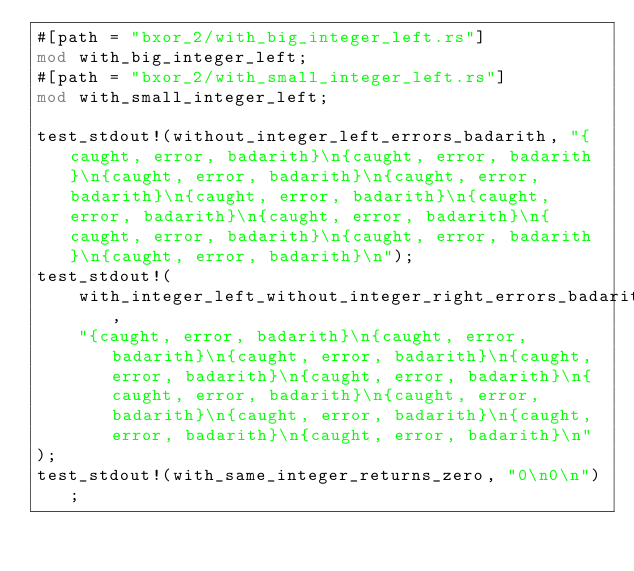Convert code to text. <code><loc_0><loc_0><loc_500><loc_500><_Rust_>#[path = "bxor_2/with_big_integer_left.rs"]
mod with_big_integer_left;
#[path = "bxor_2/with_small_integer_left.rs"]
mod with_small_integer_left;

test_stdout!(without_integer_left_errors_badarith, "{caught, error, badarith}\n{caught, error, badarith}\n{caught, error, badarith}\n{caught, error, badarith}\n{caught, error, badarith}\n{caught, error, badarith}\n{caught, error, badarith}\n{caught, error, badarith}\n{caught, error, badarith}\n{caught, error, badarith}\n");
test_stdout!(
    with_integer_left_without_integer_right_errors_badarith,
    "{caught, error, badarith}\n{caught, error, badarith}\n{caught, error, badarith}\n{caught, error, badarith}\n{caught, error, badarith}\n{caught, error, badarith}\n{caught, error, badarith}\n{caught, error, badarith}\n{caught, error, badarith}\n{caught, error, badarith}\n"
);
test_stdout!(with_same_integer_returns_zero, "0\n0\n");
</code> 